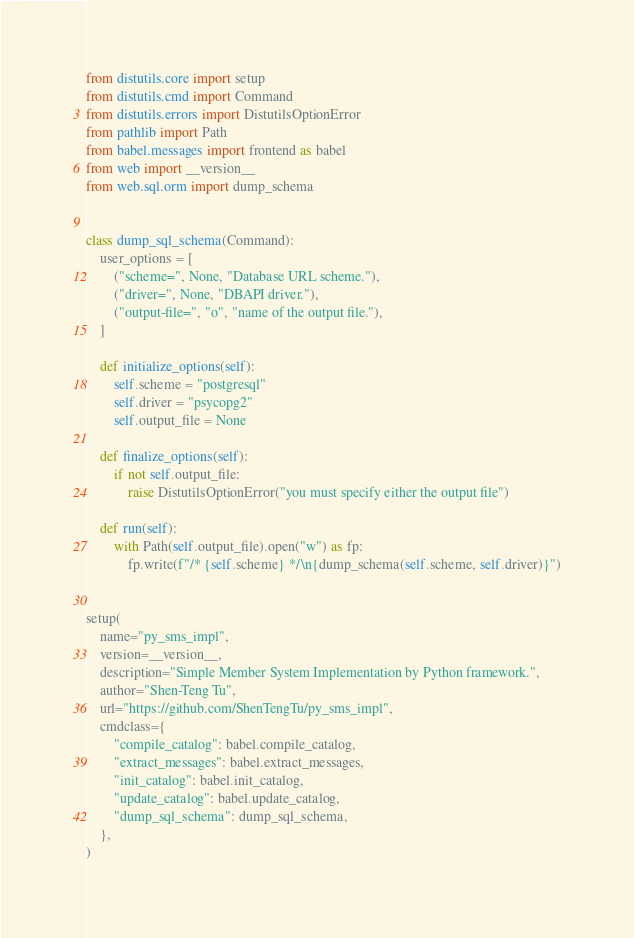Convert code to text. <code><loc_0><loc_0><loc_500><loc_500><_Python_>from distutils.core import setup
from distutils.cmd import Command
from distutils.errors import DistutilsOptionError
from pathlib import Path
from babel.messages import frontend as babel
from web import __version__
from web.sql.orm import dump_schema


class dump_sql_schema(Command):
    user_options = [
        ("scheme=", None, "Database URL scheme."),
        ("driver=", None, "DBAPI driver."),
        ("output-file=", "o", "name of the output file."),
    ]

    def initialize_options(self):
        self.scheme = "postgresql"
        self.driver = "psycopg2"
        self.output_file = None

    def finalize_options(self):
        if not self.output_file:
            raise DistutilsOptionError("you must specify either the output file")

    def run(self):
        with Path(self.output_file).open("w") as fp:
            fp.write(f"/* {self.scheme} */\n{dump_schema(self.scheme, self.driver)}")


setup(
    name="py_sms_impl",
    version=__version__,
    description="Simple Member System Implementation by Python framework.",
    author="Shen-Teng Tu",
    url="https://github.com/ShenTengTu/py_sms_impl",
    cmdclass={
        "compile_catalog": babel.compile_catalog,
        "extract_messages": babel.extract_messages,
        "init_catalog": babel.init_catalog,
        "update_catalog": babel.update_catalog,
        "dump_sql_schema": dump_sql_schema,
    },
)
</code> 